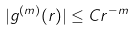<formula> <loc_0><loc_0><loc_500><loc_500>| g ^ { ( m ) } ( r ) | \leq C r ^ { - m }</formula> 